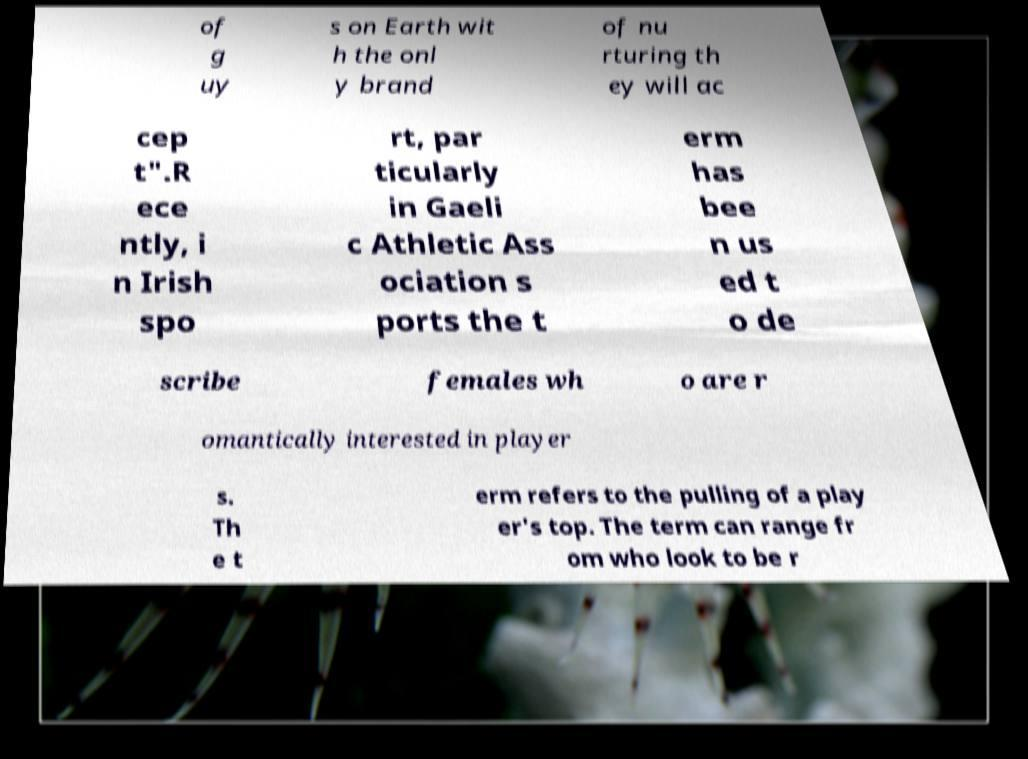Can you accurately transcribe the text from the provided image for me? of g uy s on Earth wit h the onl y brand of nu rturing th ey will ac cep t".R ece ntly, i n Irish spo rt, par ticularly in Gaeli c Athletic Ass ociation s ports the t erm has bee n us ed t o de scribe females wh o are r omantically interested in player s. Th e t erm refers to the pulling of a play er's top. The term can range fr om who look to be r 